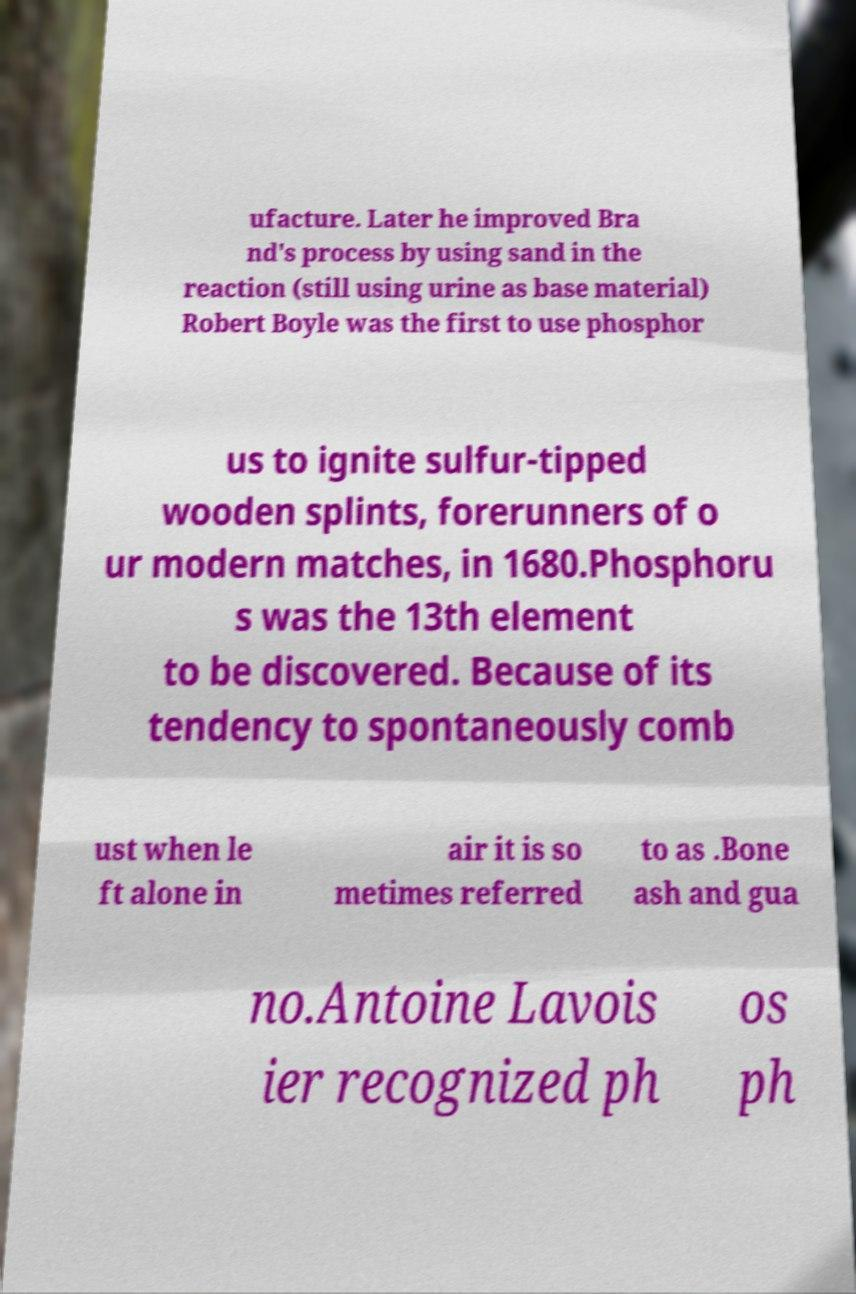Could you assist in decoding the text presented in this image and type it out clearly? ufacture. Later he improved Bra nd's process by using sand in the reaction (still using urine as base material) Robert Boyle was the first to use phosphor us to ignite sulfur-tipped wooden splints, forerunners of o ur modern matches, in 1680.Phosphoru s was the 13th element to be discovered. Because of its tendency to spontaneously comb ust when le ft alone in air it is so metimes referred to as .Bone ash and gua no.Antoine Lavois ier recognized ph os ph 